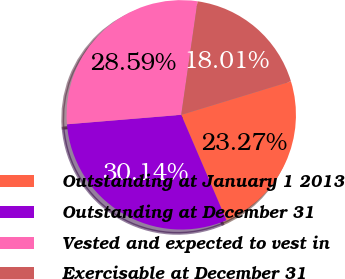Convert chart to OTSL. <chart><loc_0><loc_0><loc_500><loc_500><pie_chart><fcel>Outstanding at January 1 2013<fcel>Outstanding at December 31<fcel>Vested and expected to vest in<fcel>Exercisable at December 31<nl><fcel>23.27%<fcel>30.14%<fcel>28.59%<fcel>18.01%<nl></chart> 